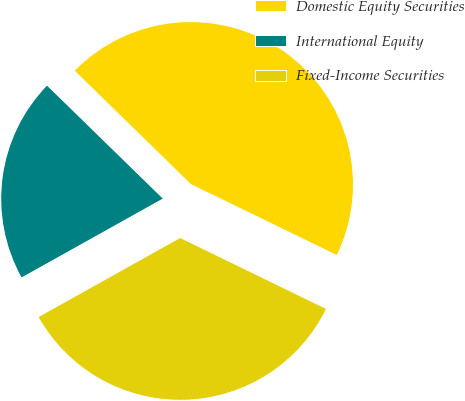Convert chart. <chart><loc_0><loc_0><loc_500><loc_500><pie_chart><fcel>Domestic Equity Securities<fcel>International Equity<fcel>Fixed-Income Securities<nl><fcel>44.9%<fcel>20.41%<fcel>34.69%<nl></chart> 